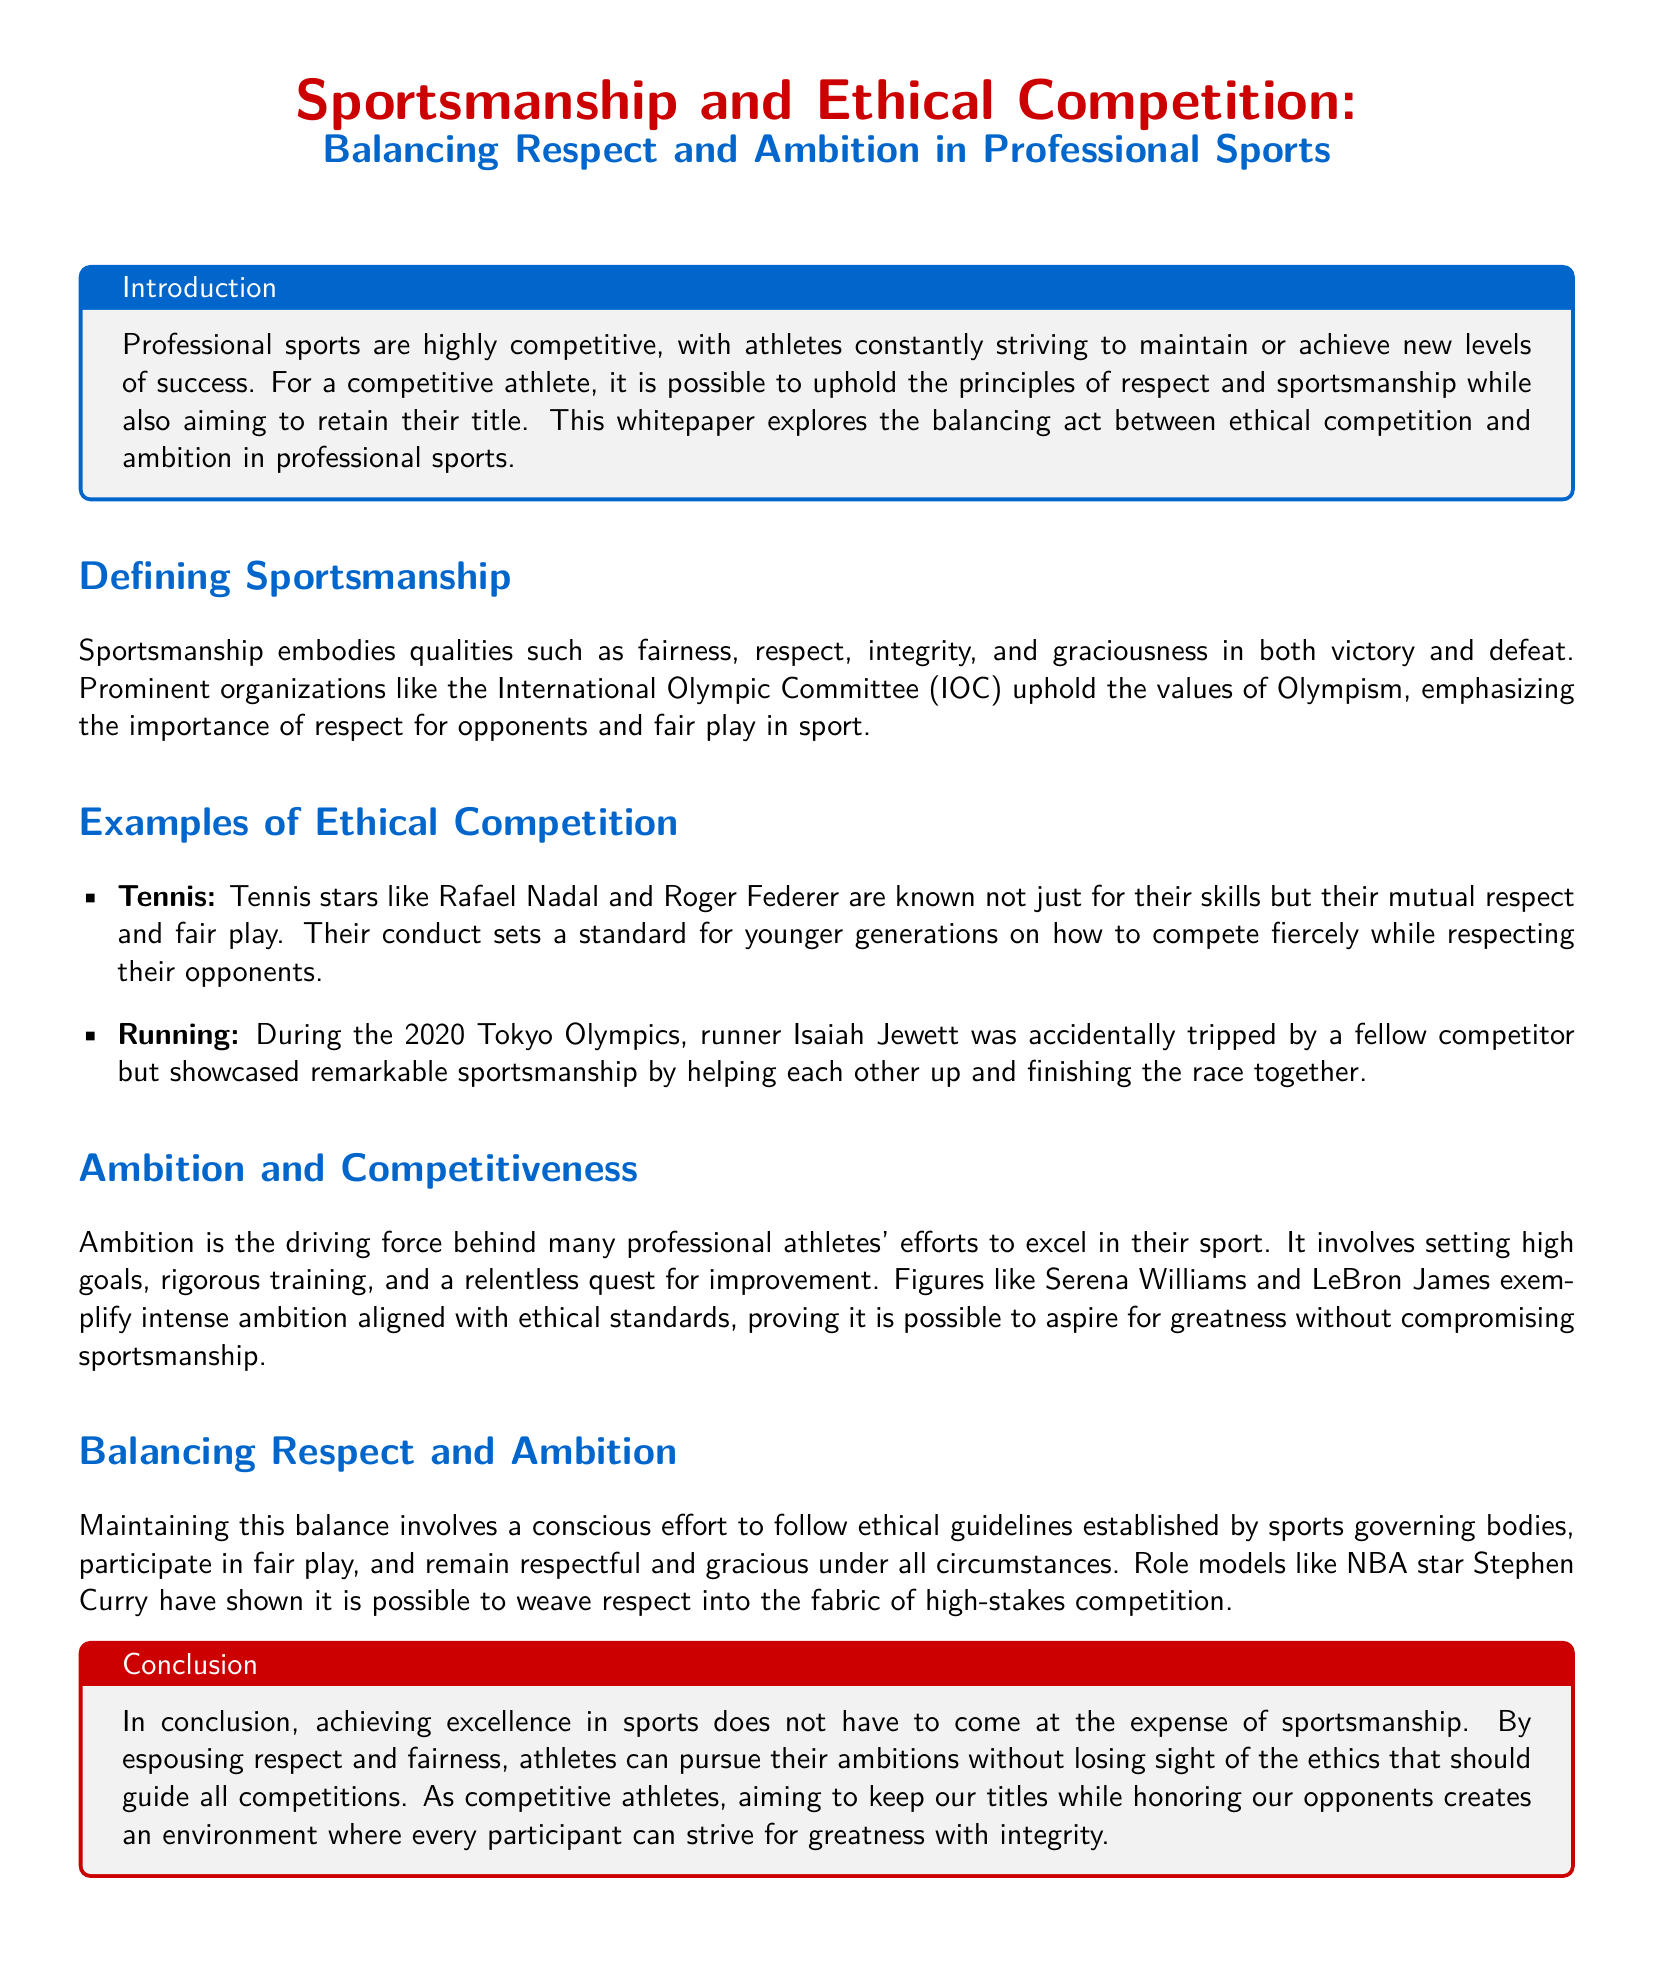What is the title of the whitepaper? The title of the whitepaper is presented at the beginning, indicating the focus on sportsmanship and ethical competition.
Answer: Sportsmanship and Ethical Competition: Balancing Respect and Ambition in Professional Sports Who are the notable tennis players mentioned for their sportsmanship? The document highlights tennis stars known for mutual respect and fair play to set an example.
Answer: Rafael Nadal and Roger Federer What event showcased Isaiah Jewett's sportsmanship? The document refers to an incident during a specific Olympic event where outstanding sportsmanship was displayed.
Answer: 2020 Tokyo Olympics Which athlete exemplifies intense ambition alongside ethical standards, as mentioned in the whitepaper? The whitepaper includes a well-known athlete recognized for their ambition and sportsmanship.
Answer: Serena Williams What qualities does sportsmanship embody according to the document? The document lists specific qualities characteristic of sportsmanship.
Answer: Fairness, respect, integrity, and graciousness What is the primary conclusion drawn in the whitepaper? The conclusion summarizes the core message regarding sportsmanship and ambition in sports.
Answer: Achieving excellence in sports does not have to come at the expense of sportsmanship Who is cited as a model for balancing respect and ambition? The document features a prominent athlete as an example of successful integration of respect into competition.
Answer: Stephen Curry What organization is mentioned as upholding the values of Olympism? The document references a major organization that promotes respect and fair play in sports.
Answer: International Olympic Committee (IOC) 